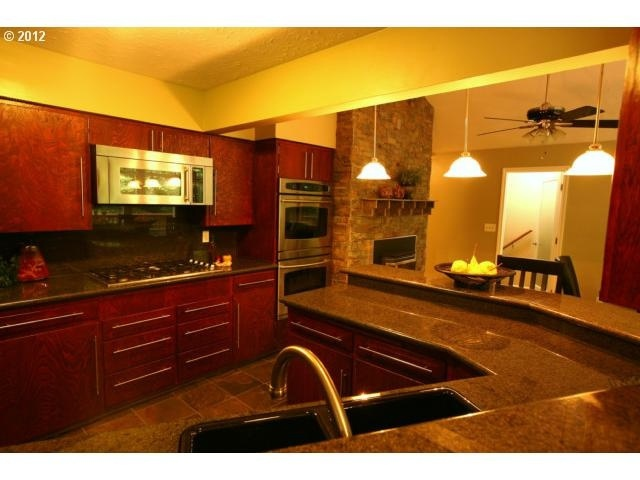Describe the objects in this image and their specific colors. I can see sink in white, black, maroon, and gray tones, microwave in white, tan, khaki, and olive tones, oven in white, black, maroon, and olive tones, chair in white, black, maroon, olive, and orange tones, and bowl in white, maroon, black, gold, and brown tones in this image. 